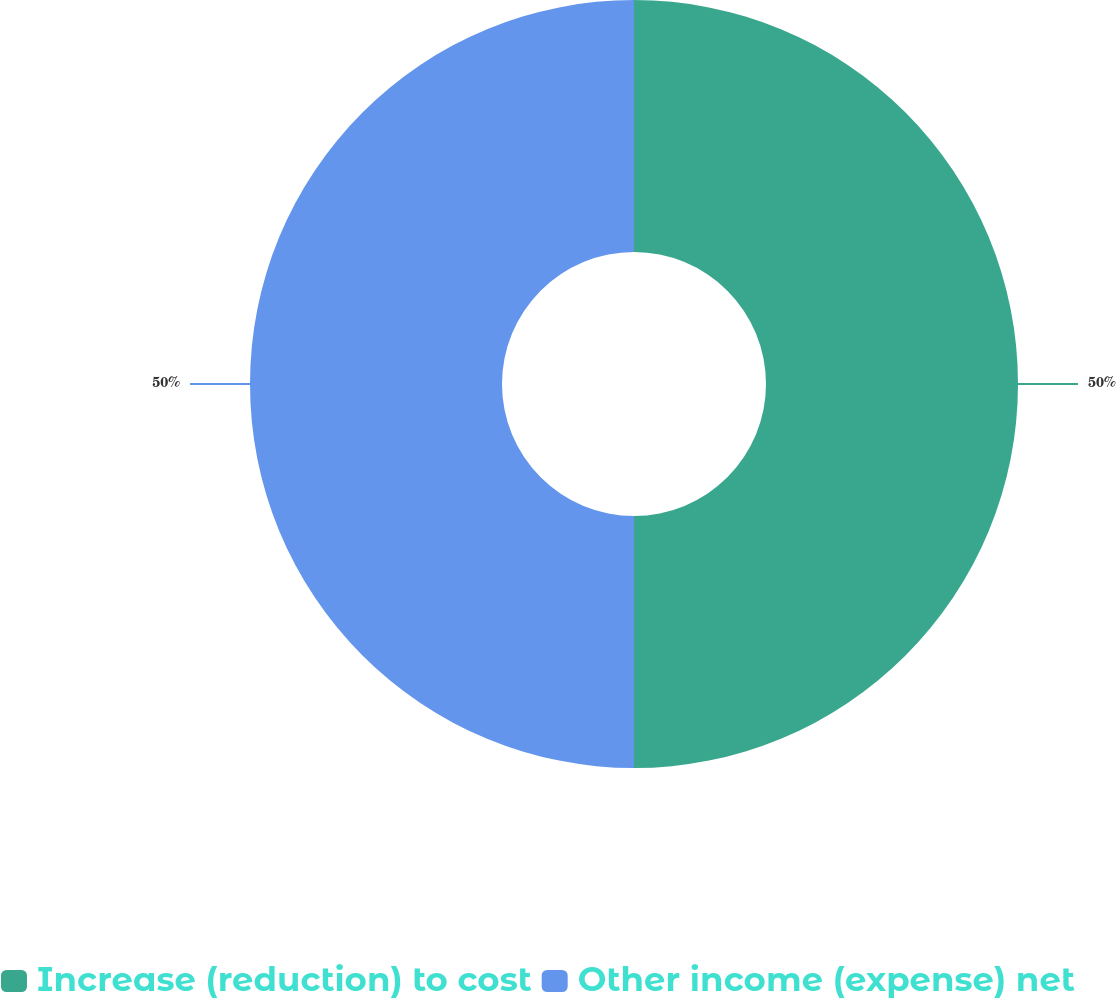Convert chart. <chart><loc_0><loc_0><loc_500><loc_500><pie_chart><fcel>Increase (reduction) to cost<fcel>Other income (expense) net<nl><fcel>50.0%<fcel>50.0%<nl></chart> 